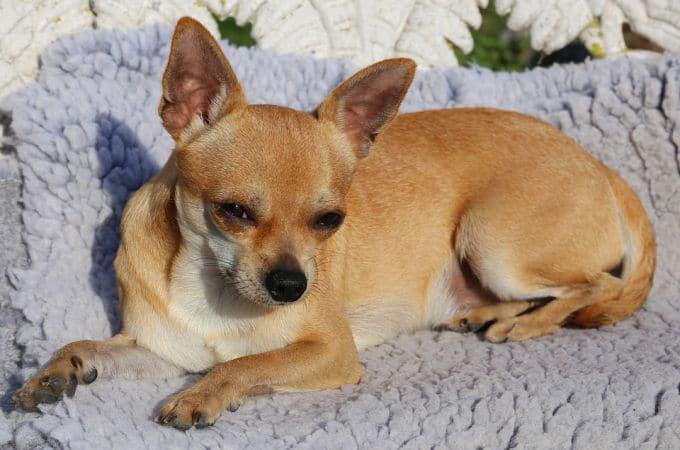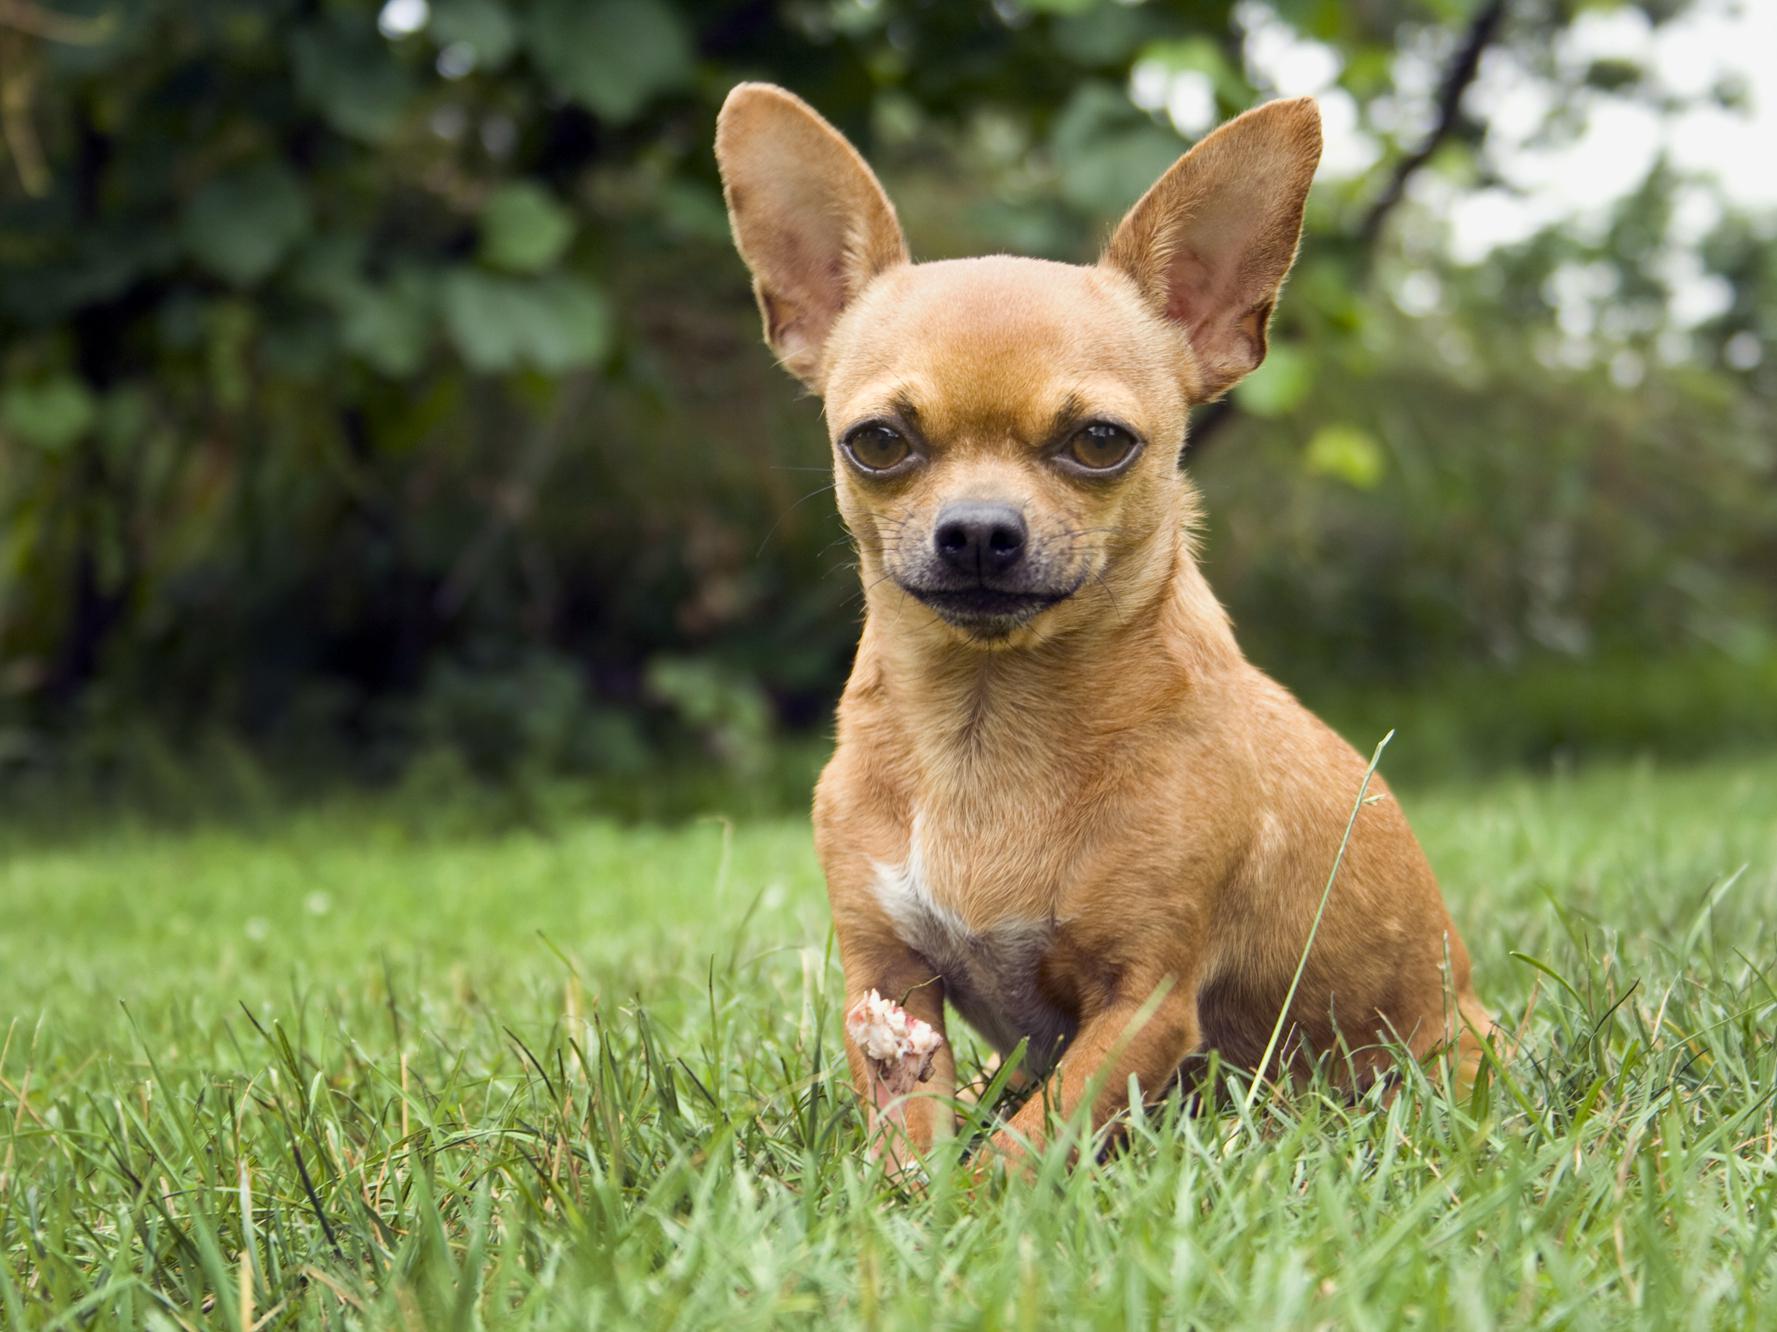The first image is the image on the left, the second image is the image on the right. Considering the images on both sides, is "The dogs in the image on the right are sitting on grass." valid? Answer yes or no. Yes. 